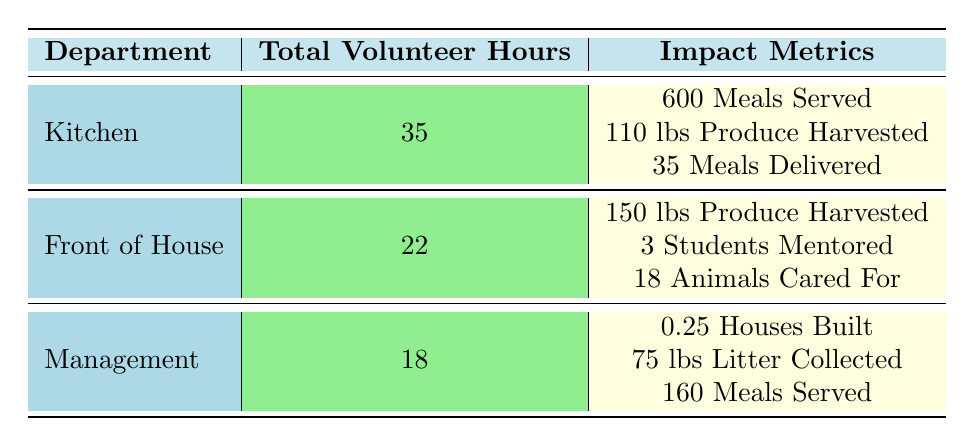What is the total number of volunteer hours contributed by the Kitchen department? The table shows that the Kitchen department has 35 total volunteer hours listed.
Answer: 35 What impact metric value was achieved for the Front of House department? The Front of House department shows three impact metrics: 150 pounds of produce harvested, 3 students mentored, and 18 animals cared for. The total values for these metrics are represented separately.
Answer: 150 pounds of produce harvested, 3 students mentored, 18 animals cared for Does the Management department have any recorded Meals Served impact? The Management department shows an impact metric of 160 Meals Served. This indicates that they do have recorded Meals Served impact.
Answer: Yes Which department has the highest total impact value? To determine this, we can look at the impact metrics listed: Kitchen has a total impact of 600 Meals Served + 110 lbs Produce Harvested + 35 Meals Delivered. Front of House has a total of 150 lbs Produce Harvested + 3 Students Mentored + 18 Animals Cared For. Management has 0.25 Houses Built + 75 lbs Litter Collected + 160 Meals Served. Summing these values indicates that the Kitchen department has the highest.
Answer: Kitchen How many impact metrics does the Kitchen department report? The Kitchen department shows three different impact metrics recorded: Meals Served, Pounds of Produce Harvested, and Meals Delivered. Therefore, it reports three impact metrics in total.
Answer: 3 What is the average number of volunteer hours across all departments? To find the average number of volunteer hours, sum the total hours from each department (35 for Kitchen, 22 for Front of House, and 18 for Management) which is 35 + 22 + 18 = 75. There are 3 departments, so the average is 75 / 3 = 25.
Answer: 25 Is the total volunteer hours for Front of House greater than that for Management? The total volunteer hours for the Front of House is 22, while for Management it is 18. Since 22 is greater than 18, it indicates the Front of House has more hours.
Answer: Yes What is the total impact value for the Management department? The Management department has three impact metrics: 0.25 Houses Built, 75 lbs Litter Collected, and 160 Meals Served. The total impact=sum(0.25+75+160)=235.
Answer: 235 Which department contributed to the Youth Mentoring Program? The data shows that David Rodriguez, from the Front of House department, contributed to the Youth Mentoring Program, with 5 volunteer hours and 3 students mentored.
Answer: Front of House 